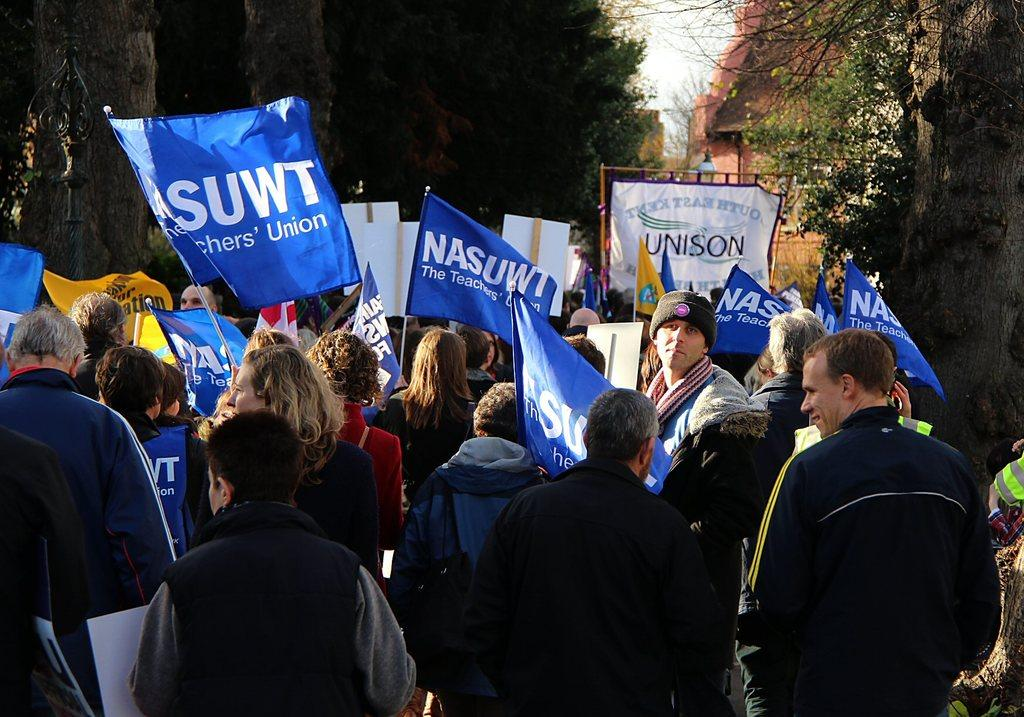What is happening in the image involving the group of people? The people in the image are standing and holding placards and flags. What might the people be trying to convey with their placards and flags? It is likely that the people are participating in a protest or demonstration, expressing their opinions or beliefs. What can be seen in the background of the image? There are trees and a building in the background of the image. What type of school can be seen in the image? There is no school present in the image. Is the group of people in the image walking through the wilderness? The image does not depict a wilderness setting; there are trees and a building in the background, suggesting an urban or suburban environment. 